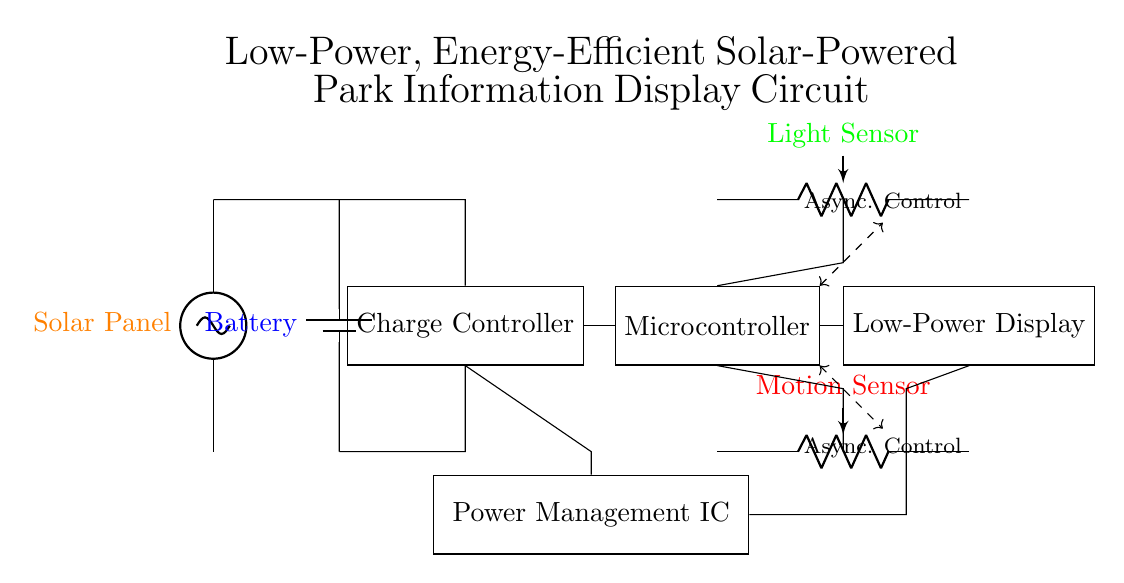What is the main power source for this circuit? The solar panel, depicted at the top left of the diagram, serves as the main power source, providing energy to the circuit.
Answer: Solar Panel Which component stores energy in this circuit? The battery, located at the second position from the left, is responsible for storing energy collected from the solar panel for use when needed.
Answer: Battery What control component is indicated in the circuit? The microcontroller, shown in the middle section of the diagram, controls the operation of the display and responds to sensor inputs.
Answer: Microcontroller How does the light sensor interact with the microcontroller? The light sensor is connected to the microcontroller, allowing it to provide input about the surrounding light levels, which can influence the display's operation.
Answer: Input What is the purpose of the charge controller? The charge controller manages the flow of energy from the solar panel to the battery, ensuring the battery is charged appropriately and preventing overcharging.
Answer: Energy management Identify the type of components used for sensing. The circuit includes both a light sensor and a motion sensor, which serve to detect environmental conditions and user presence.
Answer: Light Sensor, Motion Sensor What kind of control is emphasized in the circuit's design? Asynchronous control is emphasized, indicated by dashed lines showing the interaction between the microcontroller and other components, allowing for non-blocking operations.
Answer: Asynchronous Control 